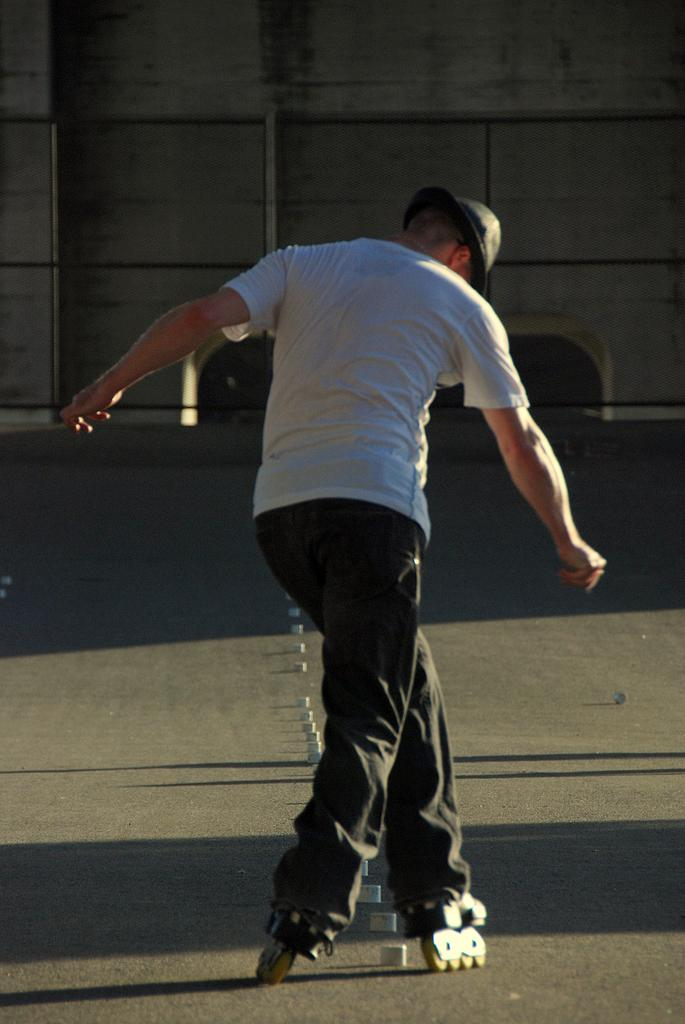Who is the person in the image? There is a man in the image. What is the man doing in the image? The man is skating on a path. Are there any objects on the path? Yes, there are objects on the path. What is in front of the man while he is skating? There is a wall in front of the man. What type of pen is the man using to write on the level in the image? There is no pen or level present in the image; the man is skating on a path with a wall in front of him. 